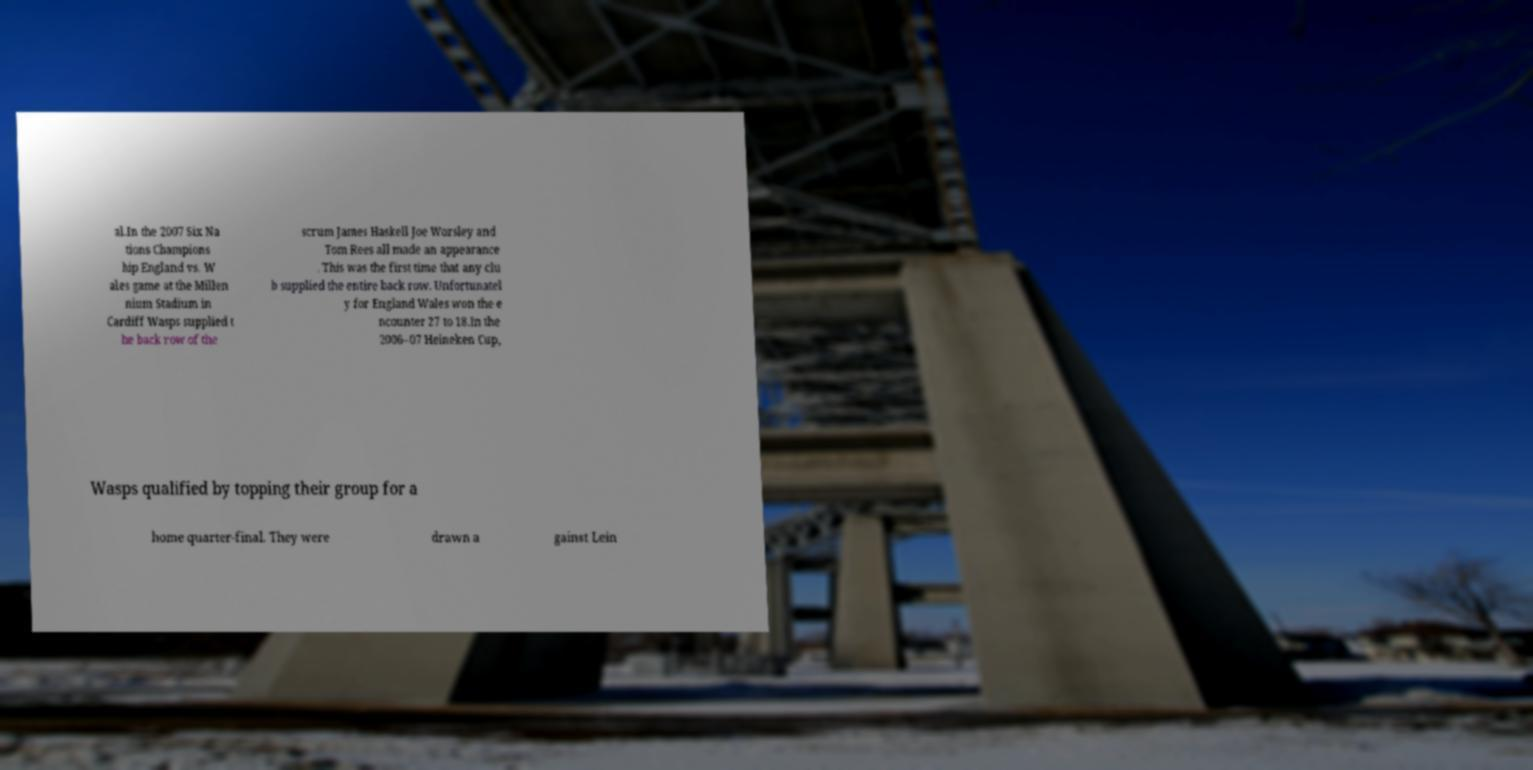Could you extract and type out the text from this image? al.In the 2007 Six Na tions Champions hip England vs. W ales game at the Millen nium Stadium in Cardiff Wasps supplied t he back row of the scrum James Haskell Joe Worsley and Tom Rees all made an appearance . This was the first time that any clu b supplied the entire back row. Unfortunatel y for England Wales won the e ncounter 27 to 18.In the 2006–07 Heineken Cup, Wasps qualified by topping their group for a home quarter-final. They were drawn a gainst Lein 